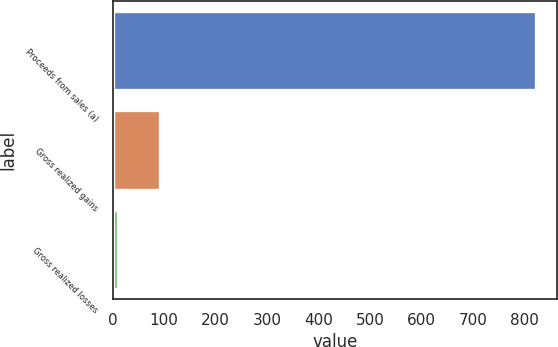Convert chart to OTSL. <chart><loc_0><loc_0><loc_500><loc_500><bar_chart><fcel>Proceeds from sales (a)<fcel>Gross realized gains<fcel>Gross realized losses<nl><fcel>823<fcel>91.3<fcel>10<nl></chart> 